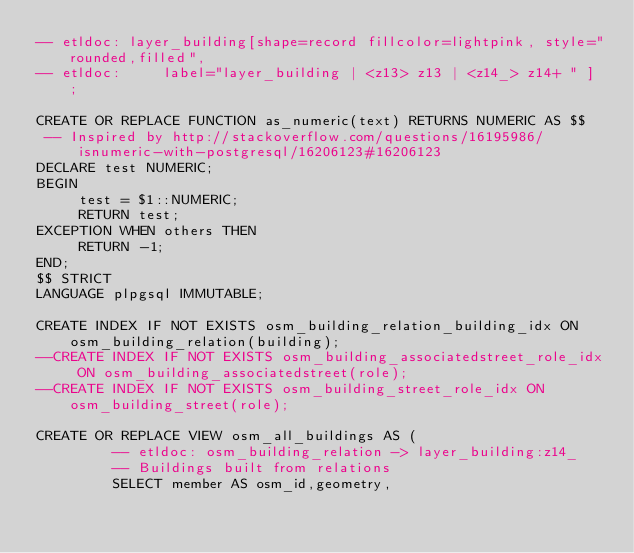<code> <loc_0><loc_0><loc_500><loc_500><_SQL_>-- etldoc: layer_building[shape=record fillcolor=lightpink, style="rounded,filled",
-- etldoc:     label="layer_building | <z13> z13 | <z14_> z14+ " ] ;

CREATE OR REPLACE FUNCTION as_numeric(text) RETURNS NUMERIC AS $$
 -- Inspired by http://stackoverflow.com/questions/16195986/isnumeric-with-postgresql/16206123#16206123
DECLARE test NUMERIC;
BEGIN
     test = $1::NUMERIC;
     RETURN test;
EXCEPTION WHEN others THEN
     RETURN -1;
END;
$$ STRICT
LANGUAGE plpgsql IMMUTABLE;

CREATE INDEX IF NOT EXISTS osm_building_relation_building_idx ON osm_building_relation(building);
--CREATE INDEX IF NOT EXISTS osm_building_associatedstreet_role_idx ON osm_building_associatedstreet(role);
--CREATE INDEX IF NOT EXISTS osm_building_street_role_idx ON osm_building_street(role);

CREATE OR REPLACE VIEW osm_all_buildings AS (
         -- etldoc: osm_building_relation -> layer_building:z14_
         -- Buildings built from relations
         SELECT member AS osm_id,geometry,</code> 